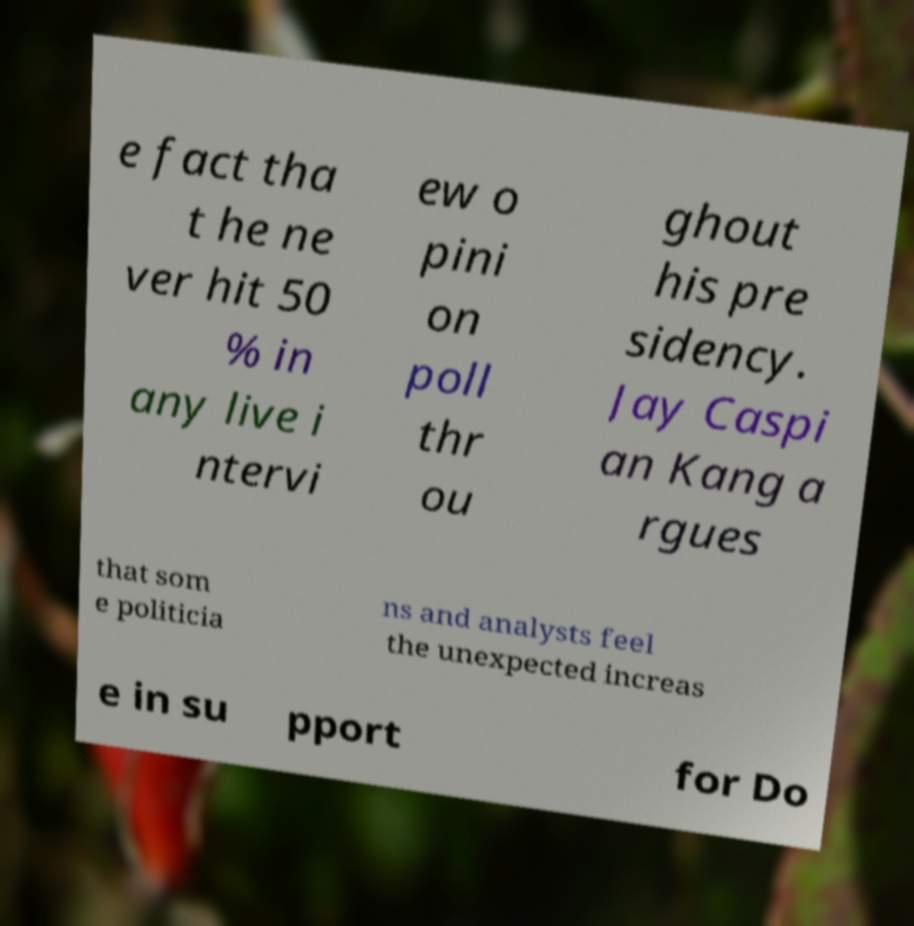Can you accurately transcribe the text from the provided image for me? e fact tha t he ne ver hit 50 % in any live i ntervi ew o pini on poll thr ou ghout his pre sidency. Jay Caspi an Kang a rgues that som e politicia ns and analysts feel the unexpected increas e in su pport for Do 